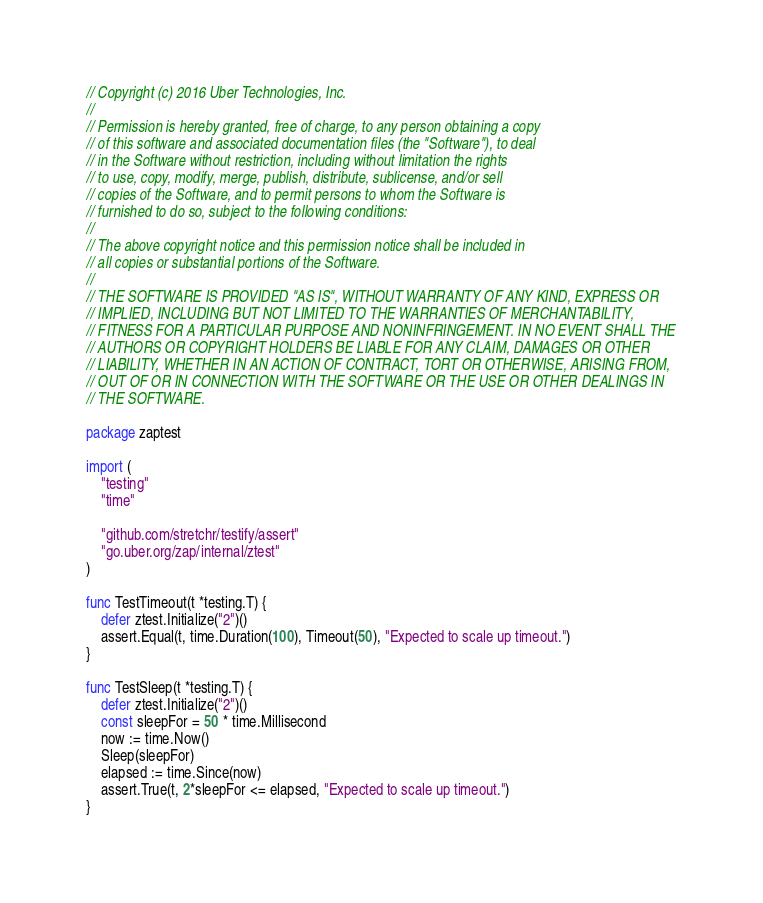<code> <loc_0><loc_0><loc_500><loc_500><_Go_>// Copyright (c) 2016 Uber Technologies, Inc.
//
// Permission is hereby granted, free of charge, to any person obtaining a copy
// of this software and associated documentation files (the "Software"), to deal
// in the Software without restriction, including without limitation the rights
// to use, copy, modify, merge, publish, distribute, sublicense, and/or sell
// copies of the Software, and to permit persons to whom the Software is
// furnished to do so, subject to the following conditions:
//
// The above copyright notice and this permission notice shall be included in
// all copies or substantial portions of the Software.
//
// THE SOFTWARE IS PROVIDED "AS IS", WITHOUT WARRANTY OF ANY KIND, EXPRESS OR
// IMPLIED, INCLUDING BUT NOT LIMITED TO THE WARRANTIES OF MERCHANTABILITY,
// FITNESS FOR A PARTICULAR PURPOSE AND NONINFRINGEMENT. IN NO EVENT SHALL THE
// AUTHORS OR COPYRIGHT HOLDERS BE LIABLE FOR ANY CLAIM, DAMAGES OR OTHER
// LIABILITY, WHETHER IN AN ACTION OF CONTRACT, TORT OR OTHERWISE, ARISING FROM,
// OUT OF OR IN CONNECTION WITH THE SOFTWARE OR THE USE OR OTHER DEALINGS IN
// THE SOFTWARE.

package zaptest

import (
	"testing"
	"time"

	"github.com/stretchr/testify/assert"
	"go.uber.org/zap/internal/ztest"
)

func TestTimeout(t *testing.T) {
	defer ztest.Initialize("2")()
	assert.Equal(t, time.Duration(100), Timeout(50), "Expected to scale up timeout.")
}

func TestSleep(t *testing.T) {
	defer ztest.Initialize("2")()
	const sleepFor = 50 * time.Millisecond
	now := time.Now()
	Sleep(sleepFor)
	elapsed := time.Since(now)
	assert.True(t, 2*sleepFor <= elapsed, "Expected to scale up timeout.")
}
</code> 